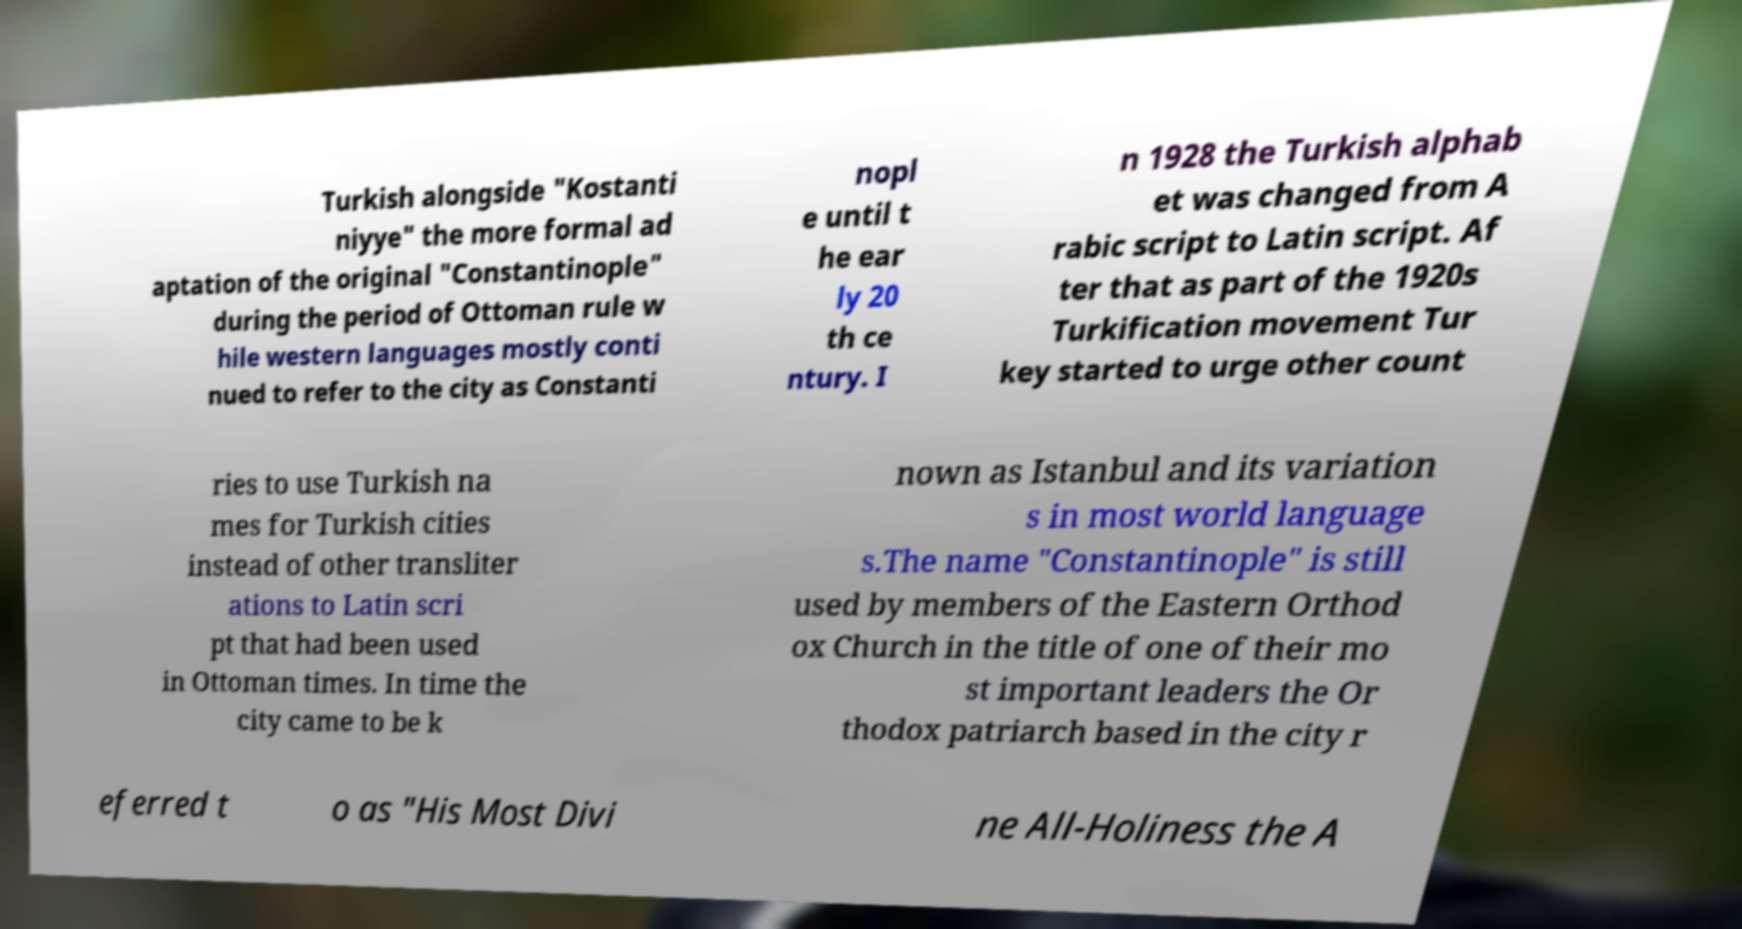For documentation purposes, I need the text within this image transcribed. Could you provide that? Turkish alongside "Kostanti niyye" the more formal ad aptation of the original "Constantinople" during the period of Ottoman rule w hile western languages mostly conti nued to refer to the city as Constanti nopl e until t he ear ly 20 th ce ntury. I n 1928 the Turkish alphab et was changed from A rabic script to Latin script. Af ter that as part of the 1920s Turkification movement Tur key started to urge other count ries to use Turkish na mes for Turkish cities instead of other transliter ations to Latin scri pt that had been used in Ottoman times. In time the city came to be k nown as Istanbul and its variation s in most world language s.The name "Constantinople" is still used by members of the Eastern Orthod ox Church in the title of one of their mo st important leaders the Or thodox patriarch based in the city r eferred t o as "His Most Divi ne All-Holiness the A 